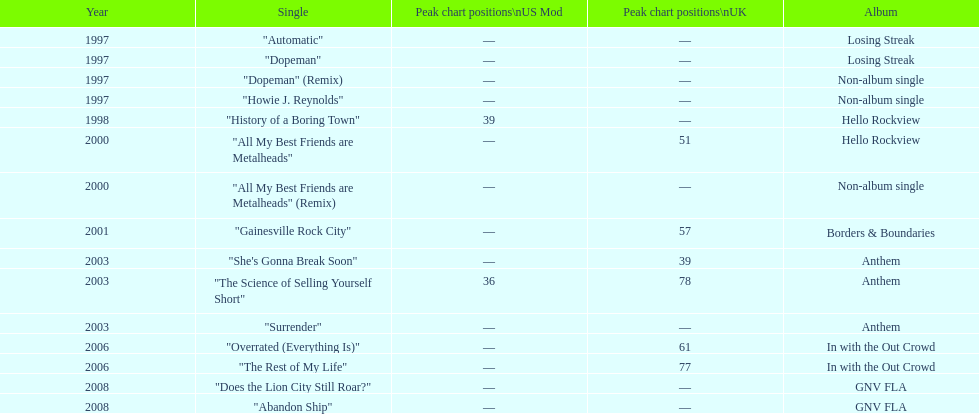What was the duration in years between losing streak album and gnv fla? 11. Parse the table in full. {'header': ['Year', 'Single', 'Peak chart positions\\nUS Mod', 'Peak chart positions\\nUK', 'Album'], 'rows': [['1997', '"Automatic"', '—', '—', 'Losing Streak'], ['1997', '"Dopeman"', '—', '—', 'Losing Streak'], ['1997', '"Dopeman" (Remix)', '—', '—', 'Non-album single'], ['1997', '"Howie J. Reynolds"', '—', '—', 'Non-album single'], ['1998', '"History of a Boring Town"', '39', '—', 'Hello Rockview'], ['2000', '"All My Best Friends are Metalheads"', '—', '51', 'Hello Rockview'], ['2000', '"All My Best Friends are Metalheads" (Remix)', '—', '—', 'Non-album single'], ['2001', '"Gainesville Rock City"', '—', '57', 'Borders & Boundaries'], ['2003', '"She\'s Gonna Break Soon"', '—', '39', 'Anthem'], ['2003', '"The Science of Selling Yourself Short"', '36', '78', 'Anthem'], ['2003', '"Surrender"', '—', '—', 'Anthem'], ['2006', '"Overrated (Everything Is)"', '—', '61', 'In with the Out Crowd'], ['2006', '"The Rest of My Life"', '—', '77', 'In with the Out Crowd'], ['2008', '"Does the Lion City Still Roar?"', '—', '—', 'GNV FLA'], ['2008', '"Abandon Ship"', '—', '—', 'GNV FLA']]} 